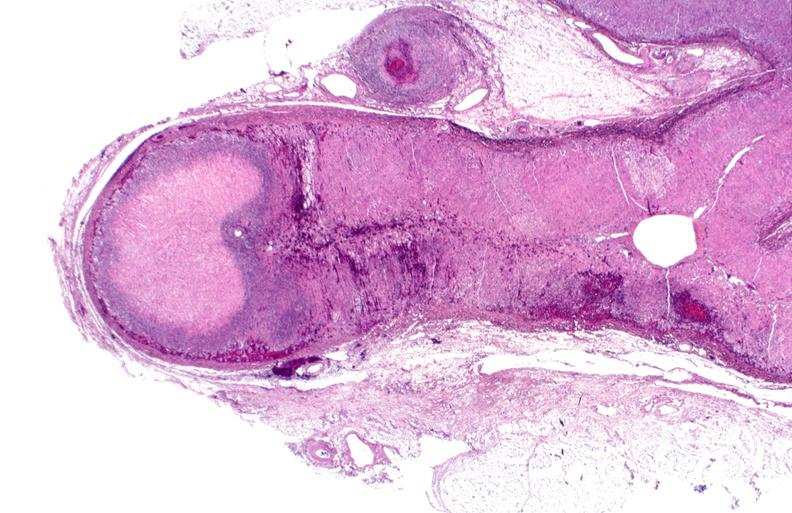how does this image show adrenal, polyarteritis nodosa?
Answer the question using a single word or phrase. With infarct 